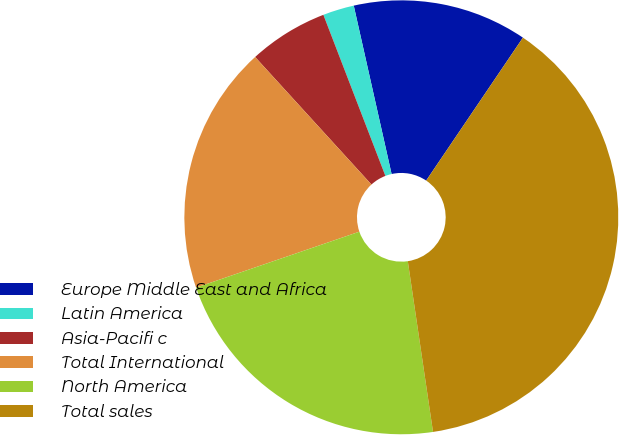<chart> <loc_0><loc_0><loc_500><loc_500><pie_chart><fcel>Europe Middle East and Africa<fcel>Latin America<fcel>Asia-Pacifi c<fcel>Total International<fcel>North America<fcel>Total sales<nl><fcel>12.99%<fcel>2.33%<fcel>5.92%<fcel>18.49%<fcel>22.08%<fcel>38.2%<nl></chart> 